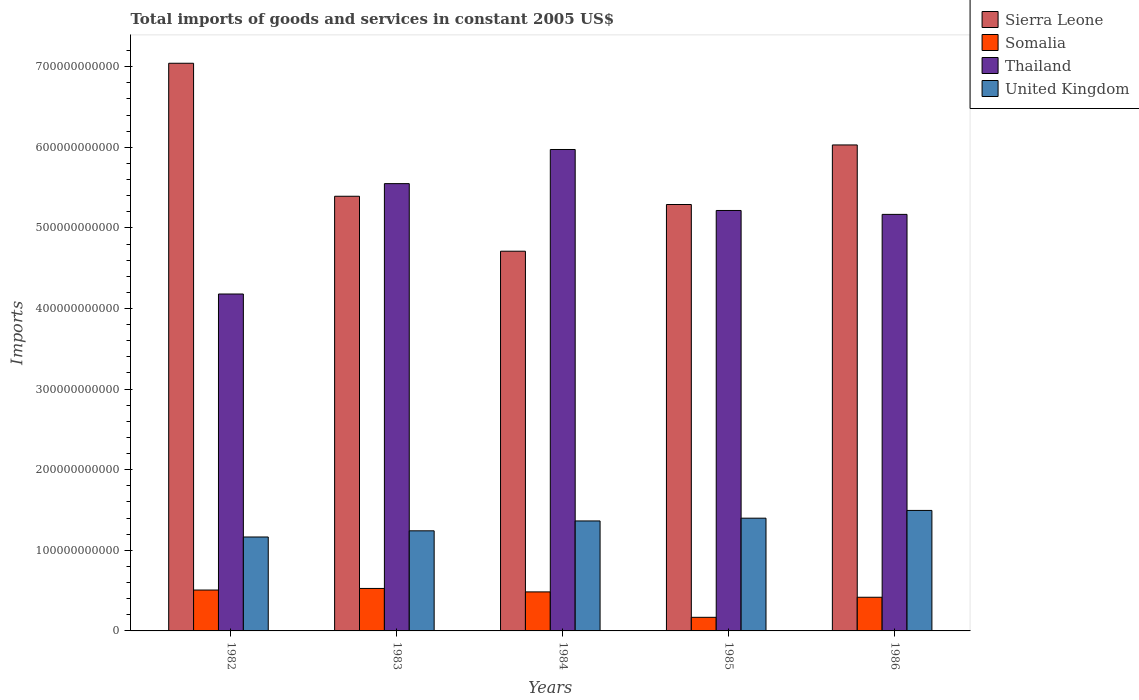How many different coloured bars are there?
Ensure brevity in your answer.  4. How many groups of bars are there?
Your answer should be very brief. 5. Are the number of bars per tick equal to the number of legend labels?
Provide a short and direct response. Yes. Are the number of bars on each tick of the X-axis equal?
Your answer should be compact. Yes. What is the total imports of goods and services in Somalia in 1983?
Your answer should be compact. 5.27e+1. Across all years, what is the maximum total imports of goods and services in Sierra Leone?
Give a very brief answer. 7.04e+11. Across all years, what is the minimum total imports of goods and services in Thailand?
Ensure brevity in your answer.  4.18e+11. In which year was the total imports of goods and services in Thailand maximum?
Make the answer very short. 1984. In which year was the total imports of goods and services in Somalia minimum?
Offer a terse response. 1985. What is the total total imports of goods and services in Thailand in the graph?
Offer a very short reply. 2.61e+12. What is the difference between the total imports of goods and services in Thailand in 1983 and that in 1984?
Ensure brevity in your answer.  -4.24e+1. What is the difference between the total imports of goods and services in United Kingdom in 1986 and the total imports of goods and services in Somalia in 1985?
Ensure brevity in your answer.  1.33e+11. What is the average total imports of goods and services in Thailand per year?
Ensure brevity in your answer.  5.22e+11. In the year 1984, what is the difference between the total imports of goods and services in Somalia and total imports of goods and services in Thailand?
Provide a short and direct response. -5.49e+11. What is the ratio of the total imports of goods and services in Thailand in 1982 to that in 1983?
Provide a succinct answer. 0.75. What is the difference between the highest and the second highest total imports of goods and services in Somalia?
Make the answer very short. 2.00e+09. What is the difference between the highest and the lowest total imports of goods and services in Somalia?
Make the answer very short. 3.58e+1. In how many years, is the total imports of goods and services in Thailand greater than the average total imports of goods and services in Thailand taken over all years?
Your response must be concise. 2. Is the sum of the total imports of goods and services in United Kingdom in 1984 and 1985 greater than the maximum total imports of goods and services in Thailand across all years?
Your answer should be compact. No. Is it the case that in every year, the sum of the total imports of goods and services in Sierra Leone and total imports of goods and services in Thailand is greater than the sum of total imports of goods and services in United Kingdom and total imports of goods and services in Somalia?
Offer a very short reply. Yes. What does the 4th bar from the right in 1982 represents?
Your response must be concise. Sierra Leone. Are all the bars in the graph horizontal?
Your answer should be very brief. No. How many years are there in the graph?
Your response must be concise. 5. What is the difference between two consecutive major ticks on the Y-axis?
Keep it short and to the point. 1.00e+11. Does the graph contain grids?
Make the answer very short. No. Where does the legend appear in the graph?
Your answer should be compact. Top right. How many legend labels are there?
Provide a succinct answer. 4. What is the title of the graph?
Give a very brief answer. Total imports of goods and services in constant 2005 US$. What is the label or title of the Y-axis?
Your response must be concise. Imports. What is the Imports in Sierra Leone in 1982?
Offer a very short reply. 7.04e+11. What is the Imports in Somalia in 1982?
Ensure brevity in your answer.  5.07e+1. What is the Imports in Thailand in 1982?
Make the answer very short. 4.18e+11. What is the Imports in United Kingdom in 1982?
Offer a terse response. 1.17e+11. What is the Imports of Sierra Leone in 1983?
Offer a very short reply. 5.39e+11. What is the Imports in Somalia in 1983?
Ensure brevity in your answer.  5.27e+1. What is the Imports in Thailand in 1983?
Your answer should be very brief. 5.55e+11. What is the Imports in United Kingdom in 1983?
Offer a terse response. 1.24e+11. What is the Imports in Sierra Leone in 1984?
Make the answer very short. 4.71e+11. What is the Imports in Somalia in 1984?
Give a very brief answer. 4.84e+1. What is the Imports in Thailand in 1984?
Offer a very short reply. 5.97e+11. What is the Imports of United Kingdom in 1984?
Your response must be concise. 1.36e+11. What is the Imports in Sierra Leone in 1985?
Provide a succinct answer. 5.29e+11. What is the Imports in Somalia in 1985?
Your response must be concise. 1.69e+1. What is the Imports in Thailand in 1985?
Give a very brief answer. 5.22e+11. What is the Imports in United Kingdom in 1985?
Provide a succinct answer. 1.40e+11. What is the Imports of Sierra Leone in 1986?
Your response must be concise. 6.03e+11. What is the Imports of Somalia in 1986?
Provide a succinct answer. 4.18e+1. What is the Imports of Thailand in 1986?
Offer a very short reply. 5.17e+11. What is the Imports in United Kingdom in 1986?
Offer a very short reply. 1.49e+11. Across all years, what is the maximum Imports in Sierra Leone?
Keep it short and to the point. 7.04e+11. Across all years, what is the maximum Imports in Somalia?
Provide a succinct answer. 5.27e+1. Across all years, what is the maximum Imports in Thailand?
Offer a terse response. 5.97e+11. Across all years, what is the maximum Imports in United Kingdom?
Offer a terse response. 1.49e+11. Across all years, what is the minimum Imports in Sierra Leone?
Ensure brevity in your answer.  4.71e+11. Across all years, what is the minimum Imports of Somalia?
Give a very brief answer. 1.69e+1. Across all years, what is the minimum Imports in Thailand?
Provide a succinct answer. 4.18e+11. Across all years, what is the minimum Imports of United Kingdom?
Give a very brief answer. 1.17e+11. What is the total Imports of Sierra Leone in the graph?
Give a very brief answer. 2.85e+12. What is the total Imports of Somalia in the graph?
Provide a short and direct response. 2.10e+11. What is the total Imports of Thailand in the graph?
Give a very brief answer. 2.61e+12. What is the total Imports of United Kingdom in the graph?
Your response must be concise. 6.66e+11. What is the difference between the Imports of Sierra Leone in 1982 and that in 1983?
Provide a succinct answer. 1.65e+11. What is the difference between the Imports in Somalia in 1982 and that in 1983?
Ensure brevity in your answer.  -2.00e+09. What is the difference between the Imports in Thailand in 1982 and that in 1983?
Give a very brief answer. -1.37e+11. What is the difference between the Imports in United Kingdom in 1982 and that in 1983?
Ensure brevity in your answer.  -7.65e+09. What is the difference between the Imports of Sierra Leone in 1982 and that in 1984?
Keep it short and to the point. 2.33e+11. What is the difference between the Imports in Somalia in 1982 and that in 1984?
Your answer should be very brief. 2.29e+09. What is the difference between the Imports of Thailand in 1982 and that in 1984?
Offer a terse response. -1.79e+11. What is the difference between the Imports of United Kingdom in 1982 and that in 1984?
Your response must be concise. -1.99e+1. What is the difference between the Imports in Sierra Leone in 1982 and that in 1985?
Your answer should be very brief. 1.75e+11. What is the difference between the Imports in Somalia in 1982 and that in 1985?
Provide a short and direct response. 3.38e+1. What is the difference between the Imports in Thailand in 1982 and that in 1985?
Give a very brief answer. -1.04e+11. What is the difference between the Imports in United Kingdom in 1982 and that in 1985?
Offer a very short reply. -2.33e+1. What is the difference between the Imports of Sierra Leone in 1982 and that in 1986?
Offer a very short reply. 1.01e+11. What is the difference between the Imports in Somalia in 1982 and that in 1986?
Offer a terse response. 8.94e+09. What is the difference between the Imports in Thailand in 1982 and that in 1986?
Make the answer very short. -9.88e+1. What is the difference between the Imports of United Kingdom in 1982 and that in 1986?
Your answer should be compact. -3.30e+1. What is the difference between the Imports of Sierra Leone in 1983 and that in 1984?
Your answer should be compact. 6.82e+1. What is the difference between the Imports in Somalia in 1983 and that in 1984?
Make the answer very short. 4.29e+09. What is the difference between the Imports in Thailand in 1983 and that in 1984?
Offer a terse response. -4.24e+1. What is the difference between the Imports in United Kingdom in 1983 and that in 1984?
Give a very brief answer. -1.23e+1. What is the difference between the Imports in Sierra Leone in 1983 and that in 1985?
Your response must be concise. 1.02e+1. What is the difference between the Imports in Somalia in 1983 and that in 1985?
Offer a very short reply. 3.58e+1. What is the difference between the Imports in Thailand in 1983 and that in 1985?
Offer a very short reply. 3.33e+1. What is the difference between the Imports in United Kingdom in 1983 and that in 1985?
Your answer should be compact. -1.57e+1. What is the difference between the Imports of Sierra Leone in 1983 and that in 1986?
Give a very brief answer. -6.37e+1. What is the difference between the Imports of Somalia in 1983 and that in 1986?
Keep it short and to the point. 1.09e+1. What is the difference between the Imports of Thailand in 1983 and that in 1986?
Provide a short and direct response. 3.81e+1. What is the difference between the Imports of United Kingdom in 1983 and that in 1986?
Provide a short and direct response. -2.53e+1. What is the difference between the Imports of Sierra Leone in 1984 and that in 1985?
Make the answer very short. -5.79e+1. What is the difference between the Imports in Somalia in 1984 and that in 1985?
Provide a succinct answer. 3.15e+1. What is the difference between the Imports of Thailand in 1984 and that in 1985?
Offer a terse response. 7.57e+1. What is the difference between the Imports of United Kingdom in 1984 and that in 1985?
Provide a succinct answer. -3.44e+09. What is the difference between the Imports in Sierra Leone in 1984 and that in 1986?
Provide a short and direct response. -1.32e+11. What is the difference between the Imports of Somalia in 1984 and that in 1986?
Keep it short and to the point. 6.65e+09. What is the difference between the Imports of Thailand in 1984 and that in 1986?
Your response must be concise. 8.05e+1. What is the difference between the Imports in United Kingdom in 1984 and that in 1986?
Make the answer very short. -1.30e+1. What is the difference between the Imports of Sierra Leone in 1985 and that in 1986?
Your answer should be very brief. -7.39e+1. What is the difference between the Imports of Somalia in 1985 and that in 1986?
Provide a succinct answer. -2.49e+1. What is the difference between the Imports in Thailand in 1985 and that in 1986?
Offer a very short reply. 4.84e+09. What is the difference between the Imports of United Kingdom in 1985 and that in 1986?
Offer a terse response. -9.61e+09. What is the difference between the Imports in Sierra Leone in 1982 and the Imports in Somalia in 1983?
Give a very brief answer. 6.52e+11. What is the difference between the Imports of Sierra Leone in 1982 and the Imports of Thailand in 1983?
Make the answer very short. 1.49e+11. What is the difference between the Imports in Sierra Leone in 1982 and the Imports in United Kingdom in 1983?
Your response must be concise. 5.80e+11. What is the difference between the Imports in Somalia in 1982 and the Imports in Thailand in 1983?
Offer a very short reply. -5.04e+11. What is the difference between the Imports of Somalia in 1982 and the Imports of United Kingdom in 1983?
Your response must be concise. -7.35e+1. What is the difference between the Imports in Thailand in 1982 and the Imports in United Kingdom in 1983?
Give a very brief answer. 2.94e+11. What is the difference between the Imports of Sierra Leone in 1982 and the Imports of Somalia in 1984?
Your response must be concise. 6.56e+11. What is the difference between the Imports in Sierra Leone in 1982 and the Imports in Thailand in 1984?
Provide a short and direct response. 1.07e+11. What is the difference between the Imports of Sierra Leone in 1982 and the Imports of United Kingdom in 1984?
Make the answer very short. 5.68e+11. What is the difference between the Imports of Somalia in 1982 and the Imports of Thailand in 1984?
Offer a very short reply. -5.47e+11. What is the difference between the Imports of Somalia in 1982 and the Imports of United Kingdom in 1984?
Offer a very short reply. -8.57e+1. What is the difference between the Imports in Thailand in 1982 and the Imports in United Kingdom in 1984?
Provide a succinct answer. 2.82e+11. What is the difference between the Imports of Sierra Leone in 1982 and the Imports of Somalia in 1985?
Your answer should be compact. 6.87e+11. What is the difference between the Imports of Sierra Leone in 1982 and the Imports of Thailand in 1985?
Provide a succinct answer. 1.83e+11. What is the difference between the Imports of Sierra Leone in 1982 and the Imports of United Kingdom in 1985?
Make the answer very short. 5.64e+11. What is the difference between the Imports of Somalia in 1982 and the Imports of Thailand in 1985?
Give a very brief answer. -4.71e+11. What is the difference between the Imports of Somalia in 1982 and the Imports of United Kingdom in 1985?
Make the answer very short. -8.92e+1. What is the difference between the Imports in Thailand in 1982 and the Imports in United Kingdom in 1985?
Your response must be concise. 2.78e+11. What is the difference between the Imports in Sierra Leone in 1982 and the Imports in Somalia in 1986?
Offer a terse response. 6.62e+11. What is the difference between the Imports in Sierra Leone in 1982 and the Imports in Thailand in 1986?
Keep it short and to the point. 1.87e+11. What is the difference between the Imports of Sierra Leone in 1982 and the Imports of United Kingdom in 1986?
Offer a terse response. 5.55e+11. What is the difference between the Imports of Somalia in 1982 and the Imports of Thailand in 1986?
Provide a succinct answer. -4.66e+11. What is the difference between the Imports of Somalia in 1982 and the Imports of United Kingdom in 1986?
Offer a very short reply. -9.88e+1. What is the difference between the Imports of Thailand in 1982 and the Imports of United Kingdom in 1986?
Your response must be concise. 2.68e+11. What is the difference between the Imports in Sierra Leone in 1983 and the Imports in Somalia in 1984?
Your answer should be compact. 4.91e+11. What is the difference between the Imports in Sierra Leone in 1983 and the Imports in Thailand in 1984?
Give a very brief answer. -5.80e+1. What is the difference between the Imports in Sierra Leone in 1983 and the Imports in United Kingdom in 1984?
Provide a short and direct response. 4.03e+11. What is the difference between the Imports of Somalia in 1983 and the Imports of Thailand in 1984?
Your answer should be compact. -5.45e+11. What is the difference between the Imports in Somalia in 1983 and the Imports in United Kingdom in 1984?
Provide a short and direct response. -8.37e+1. What is the difference between the Imports in Thailand in 1983 and the Imports in United Kingdom in 1984?
Your answer should be compact. 4.18e+11. What is the difference between the Imports in Sierra Leone in 1983 and the Imports in Somalia in 1985?
Your answer should be very brief. 5.22e+11. What is the difference between the Imports in Sierra Leone in 1983 and the Imports in Thailand in 1985?
Give a very brief answer. 1.76e+1. What is the difference between the Imports of Sierra Leone in 1983 and the Imports of United Kingdom in 1985?
Make the answer very short. 3.99e+11. What is the difference between the Imports of Somalia in 1983 and the Imports of Thailand in 1985?
Offer a very short reply. -4.69e+11. What is the difference between the Imports of Somalia in 1983 and the Imports of United Kingdom in 1985?
Offer a very short reply. -8.72e+1. What is the difference between the Imports in Thailand in 1983 and the Imports in United Kingdom in 1985?
Offer a very short reply. 4.15e+11. What is the difference between the Imports in Sierra Leone in 1983 and the Imports in Somalia in 1986?
Offer a very short reply. 4.97e+11. What is the difference between the Imports in Sierra Leone in 1983 and the Imports in Thailand in 1986?
Keep it short and to the point. 2.25e+1. What is the difference between the Imports of Sierra Leone in 1983 and the Imports of United Kingdom in 1986?
Your answer should be compact. 3.90e+11. What is the difference between the Imports of Somalia in 1983 and the Imports of Thailand in 1986?
Keep it short and to the point. -4.64e+11. What is the difference between the Imports of Somalia in 1983 and the Imports of United Kingdom in 1986?
Ensure brevity in your answer.  -9.68e+1. What is the difference between the Imports of Thailand in 1983 and the Imports of United Kingdom in 1986?
Keep it short and to the point. 4.05e+11. What is the difference between the Imports of Sierra Leone in 1984 and the Imports of Somalia in 1985?
Make the answer very short. 4.54e+11. What is the difference between the Imports in Sierra Leone in 1984 and the Imports in Thailand in 1985?
Offer a very short reply. -5.05e+1. What is the difference between the Imports in Sierra Leone in 1984 and the Imports in United Kingdom in 1985?
Offer a terse response. 3.31e+11. What is the difference between the Imports of Somalia in 1984 and the Imports of Thailand in 1985?
Your response must be concise. -4.73e+11. What is the difference between the Imports of Somalia in 1984 and the Imports of United Kingdom in 1985?
Ensure brevity in your answer.  -9.15e+1. What is the difference between the Imports of Thailand in 1984 and the Imports of United Kingdom in 1985?
Your answer should be compact. 4.57e+11. What is the difference between the Imports in Sierra Leone in 1984 and the Imports in Somalia in 1986?
Make the answer very short. 4.29e+11. What is the difference between the Imports in Sierra Leone in 1984 and the Imports in Thailand in 1986?
Make the answer very short. -4.57e+1. What is the difference between the Imports in Sierra Leone in 1984 and the Imports in United Kingdom in 1986?
Provide a succinct answer. 3.22e+11. What is the difference between the Imports of Somalia in 1984 and the Imports of Thailand in 1986?
Offer a terse response. -4.68e+11. What is the difference between the Imports in Somalia in 1984 and the Imports in United Kingdom in 1986?
Your answer should be very brief. -1.01e+11. What is the difference between the Imports in Thailand in 1984 and the Imports in United Kingdom in 1986?
Your answer should be very brief. 4.48e+11. What is the difference between the Imports in Sierra Leone in 1985 and the Imports in Somalia in 1986?
Make the answer very short. 4.87e+11. What is the difference between the Imports of Sierra Leone in 1985 and the Imports of Thailand in 1986?
Offer a very short reply. 1.23e+1. What is the difference between the Imports of Sierra Leone in 1985 and the Imports of United Kingdom in 1986?
Provide a short and direct response. 3.80e+11. What is the difference between the Imports of Somalia in 1985 and the Imports of Thailand in 1986?
Your response must be concise. -5.00e+11. What is the difference between the Imports in Somalia in 1985 and the Imports in United Kingdom in 1986?
Your response must be concise. -1.33e+11. What is the difference between the Imports of Thailand in 1985 and the Imports of United Kingdom in 1986?
Provide a succinct answer. 3.72e+11. What is the average Imports in Sierra Leone per year?
Keep it short and to the point. 5.69e+11. What is the average Imports in Somalia per year?
Provide a succinct answer. 4.21e+1. What is the average Imports in Thailand per year?
Give a very brief answer. 5.22e+11. What is the average Imports in United Kingdom per year?
Provide a short and direct response. 1.33e+11. In the year 1982, what is the difference between the Imports of Sierra Leone and Imports of Somalia?
Your answer should be very brief. 6.54e+11. In the year 1982, what is the difference between the Imports of Sierra Leone and Imports of Thailand?
Offer a terse response. 2.86e+11. In the year 1982, what is the difference between the Imports in Sierra Leone and Imports in United Kingdom?
Ensure brevity in your answer.  5.88e+11. In the year 1982, what is the difference between the Imports in Somalia and Imports in Thailand?
Give a very brief answer. -3.67e+11. In the year 1982, what is the difference between the Imports in Somalia and Imports in United Kingdom?
Your answer should be compact. -6.58e+1. In the year 1982, what is the difference between the Imports of Thailand and Imports of United Kingdom?
Your answer should be very brief. 3.01e+11. In the year 1983, what is the difference between the Imports of Sierra Leone and Imports of Somalia?
Your answer should be very brief. 4.87e+11. In the year 1983, what is the difference between the Imports of Sierra Leone and Imports of Thailand?
Make the answer very short. -1.57e+1. In the year 1983, what is the difference between the Imports in Sierra Leone and Imports in United Kingdom?
Your answer should be compact. 4.15e+11. In the year 1983, what is the difference between the Imports of Somalia and Imports of Thailand?
Provide a succinct answer. -5.02e+11. In the year 1983, what is the difference between the Imports in Somalia and Imports in United Kingdom?
Ensure brevity in your answer.  -7.15e+1. In the year 1983, what is the difference between the Imports of Thailand and Imports of United Kingdom?
Make the answer very short. 4.31e+11. In the year 1984, what is the difference between the Imports in Sierra Leone and Imports in Somalia?
Your response must be concise. 4.23e+11. In the year 1984, what is the difference between the Imports of Sierra Leone and Imports of Thailand?
Provide a short and direct response. -1.26e+11. In the year 1984, what is the difference between the Imports in Sierra Leone and Imports in United Kingdom?
Provide a short and direct response. 3.35e+11. In the year 1984, what is the difference between the Imports of Somalia and Imports of Thailand?
Ensure brevity in your answer.  -5.49e+11. In the year 1984, what is the difference between the Imports of Somalia and Imports of United Kingdom?
Offer a very short reply. -8.80e+1. In the year 1984, what is the difference between the Imports in Thailand and Imports in United Kingdom?
Offer a terse response. 4.61e+11. In the year 1985, what is the difference between the Imports of Sierra Leone and Imports of Somalia?
Provide a succinct answer. 5.12e+11. In the year 1985, what is the difference between the Imports of Sierra Leone and Imports of Thailand?
Offer a very short reply. 7.41e+09. In the year 1985, what is the difference between the Imports of Sierra Leone and Imports of United Kingdom?
Keep it short and to the point. 3.89e+11. In the year 1985, what is the difference between the Imports of Somalia and Imports of Thailand?
Your answer should be compact. -5.05e+11. In the year 1985, what is the difference between the Imports in Somalia and Imports in United Kingdom?
Offer a very short reply. -1.23e+11. In the year 1985, what is the difference between the Imports of Thailand and Imports of United Kingdom?
Give a very brief answer. 3.82e+11. In the year 1986, what is the difference between the Imports in Sierra Leone and Imports in Somalia?
Keep it short and to the point. 5.61e+11. In the year 1986, what is the difference between the Imports of Sierra Leone and Imports of Thailand?
Your answer should be compact. 8.61e+1. In the year 1986, what is the difference between the Imports in Sierra Leone and Imports in United Kingdom?
Provide a succinct answer. 4.53e+11. In the year 1986, what is the difference between the Imports in Somalia and Imports in Thailand?
Make the answer very short. -4.75e+11. In the year 1986, what is the difference between the Imports of Somalia and Imports of United Kingdom?
Provide a short and direct response. -1.08e+11. In the year 1986, what is the difference between the Imports in Thailand and Imports in United Kingdom?
Keep it short and to the point. 3.67e+11. What is the ratio of the Imports of Sierra Leone in 1982 to that in 1983?
Your response must be concise. 1.31. What is the ratio of the Imports in Somalia in 1982 to that in 1983?
Provide a succinct answer. 0.96. What is the ratio of the Imports of Thailand in 1982 to that in 1983?
Give a very brief answer. 0.75. What is the ratio of the Imports of United Kingdom in 1982 to that in 1983?
Your response must be concise. 0.94. What is the ratio of the Imports of Sierra Leone in 1982 to that in 1984?
Your answer should be very brief. 1.5. What is the ratio of the Imports in Somalia in 1982 to that in 1984?
Keep it short and to the point. 1.05. What is the ratio of the Imports in Thailand in 1982 to that in 1984?
Offer a terse response. 0.7. What is the ratio of the Imports in United Kingdom in 1982 to that in 1984?
Provide a short and direct response. 0.85. What is the ratio of the Imports of Sierra Leone in 1982 to that in 1985?
Your answer should be compact. 1.33. What is the ratio of the Imports in Somalia in 1982 to that in 1985?
Give a very brief answer. 3.01. What is the ratio of the Imports in Thailand in 1982 to that in 1985?
Keep it short and to the point. 0.8. What is the ratio of the Imports in United Kingdom in 1982 to that in 1985?
Keep it short and to the point. 0.83. What is the ratio of the Imports in Sierra Leone in 1982 to that in 1986?
Provide a short and direct response. 1.17. What is the ratio of the Imports in Somalia in 1982 to that in 1986?
Your response must be concise. 1.21. What is the ratio of the Imports in Thailand in 1982 to that in 1986?
Your answer should be compact. 0.81. What is the ratio of the Imports in United Kingdom in 1982 to that in 1986?
Offer a very short reply. 0.78. What is the ratio of the Imports in Sierra Leone in 1983 to that in 1984?
Give a very brief answer. 1.14. What is the ratio of the Imports of Somalia in 1983 to that in 1984?
Offer a terse response. 1.09. What is the ratio of the Imports of Thailand in 1983 to that in 1984?
Ensure brevity in your answer.  0.93. What is the ratio of the Imports of United Kingdom in 1983 to that in 1984?
Offer a very short reply. 0.91. What is the ratio of the Imports of Sierra Leone in 1983 to that in 1985?
Keep it short and to the point. 1.02. What is the ratio of the Imports in Somalia in 1983 to that in 1985?
Make the answer very short. 3.12. What is the ratio of the Imports in Thailand in 1983 to that in 1985?
Your response must be concise. 1.06. What is the ratio of the Imports of United Kingdom in 1983 to that in 1985?
Ensure brevity in your answer.  0.89. What is the ratio of the Imports of Sierra Leone in 1983 to that in 1986?
Provide a short and direct response. 0.89. What is the ratio of the Imports of Somalia in 1983 to that in 1986?
Provide a short and direct response. 1.26. What is the ratio of the Imports in Thailand in 1983 to that in 1986?
Your response must be concise. 1.07. What is the ratio of the Imports in United Kingdom in 1983 to that in 1986?
Keep it short and to the point. 0.83. What is the ratio of the Imports of Sierra Leone in 1984 to that in 1985?
Make the answer very short. 0.89. What is the ratio of the Imports of Somalia in 1984 to that in 1985?
Give a very brief answer. 2.87. What is the ratio of the Imports in Thailand in 1984 to that in 1985?
Your answer should be very brief. 1.15. What is the ratio of the Imports in United Kingdom in 1984 to that in 1985?
Keep it short and to the point. 0.98. What is the ratio of the Imports in Sierra Leone in 1984 to that in 1986?
Your answer should be very brief. 0.78. What is the ratio of the Imports of Somalia in 1984 to that in 1986?
Provide a short and direct response. 1.16. What is the ratio of the Imports in Thailand in 1984 to that in 1986?
Give a very brief answer. 1.16. What is the ratio of the Imports of United Kingdom in 1984 to that in 1986?
Offer a terse response. 0.91. What is the ratio of the Imports in Sierra Leone in 1985 to that in 1986?
Your response must be concise. 0.88. What is the ratio of the Imports of Somalia in 1985 to that in 1986?
Offer a very short reply. 0.4. What is the ratio of the Imports of Thailand in 1985 to that in 1986?
Offer a very short reply. 1.01. What is the ratio of the Imports in United Kingdom in 1985 to that in 1986?
Provide a succinct answer. 0.94. What is the difference between the highest and the second highest Imports in Sierra Leone?
Ensure brevity in your answer.  1.01e+11. What is the difference between the highest and the second highest Imports in Somalia?
Offer a terse response. 2.00e+09. What is the difference between the highest and the second highest Imports of Thailand?
Provide a short and direct response. 4.24e+1. What is the difference between the highest and the second highest Imports in United Kingdom?
Ensure brevity in your answer.  9.61e+09. What is the difference between the highest and the lowest Imports of Sierra Leone?
Give a very brief answer. 2.33e+11. What is the difference between the highest and the lowest Imports of Somalia?
Your answer should be very brief. 3.58e+1. What is the difference between the highest and the lowest Imports in Thailand?
Your answer should be very brief. 1.79e+11. What is the difference between the highest and the lowest Imports of United Kingdom?
Offer a terse response. 3.30e+1. 